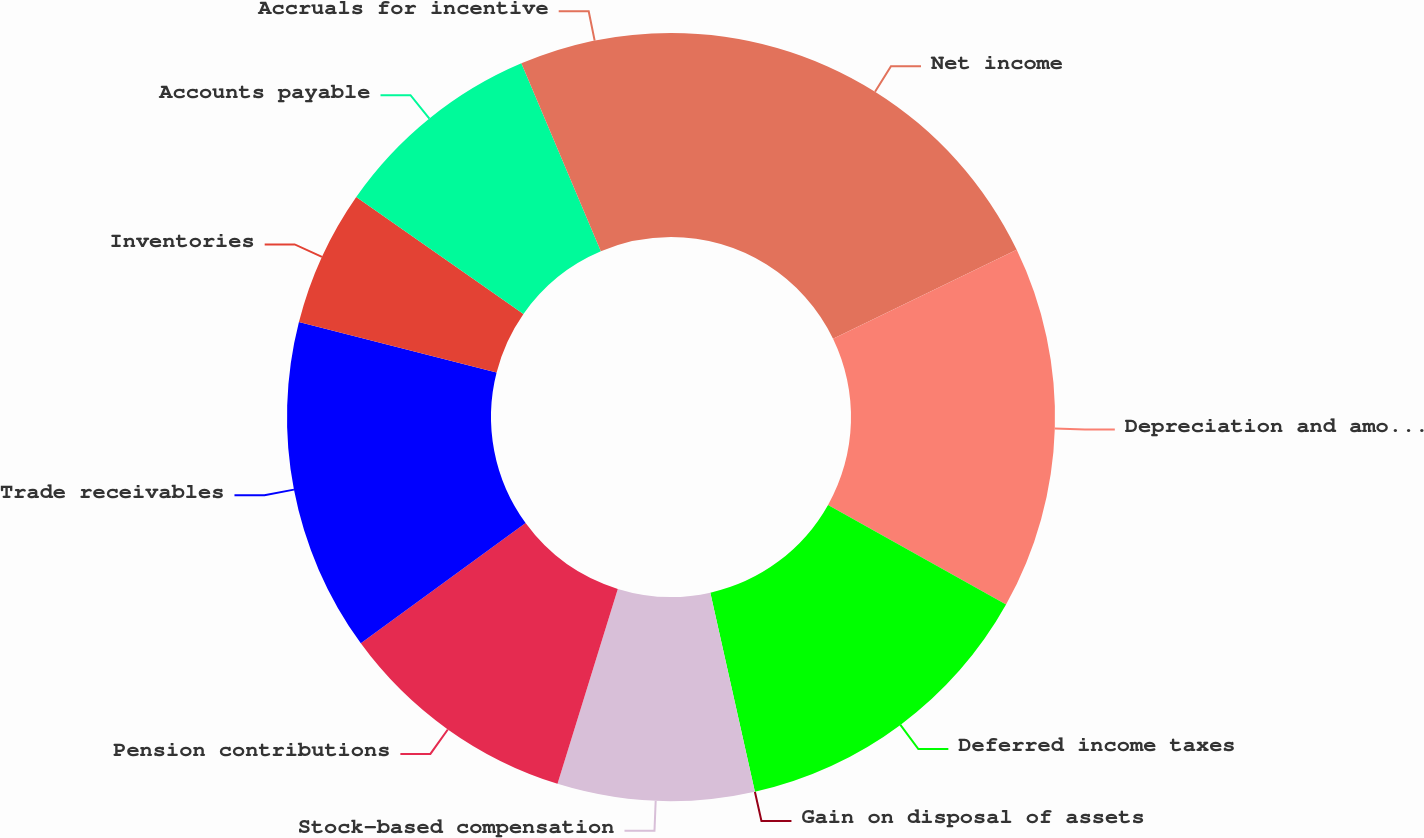Convert chart. <chart><loc_0><loc_0><loc_500><loc_500><pie_chart><fcel>Net income<fcel>Depreciation and amortization<fcel>Deferred income taxes<fcel>Gain on disposal of assets<fcel>Stock-based compensation<fcel>Pension contributions<fcel>Trade receivables<fcel>Inventories<fcel>Accounts payable<fcel>Accruals for incentive<nl><fcel>17.83%<fcel>15.29%<fcel>13.37%<fcel>0.0%<fcel>8.28%<fcel>10.19%<fcel>14.01%<fcel>5.73%<fcel>8.92%<fcel>6.37%<nl></chart> 